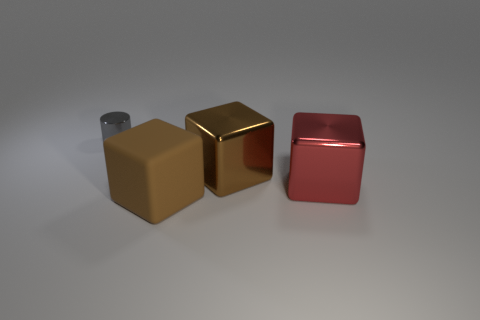How many other things are the same color as the rubber block?
Your response must be concise. 1. There is a large rubber object; does it have the same color as the large metallic block that is left of the red metallic cube?
Give a very brief answer. Yes. How many other small objects have the same shape as the gray thing?
Keep it short and to the point. 0. There is another large thing that is the same color as the rubber object; what is its material?
Provide a short and direct response. Metal. What number of large cyan balls are there?
Ensure brevity in your answer.  0. Is there a cylinder made of the same material as the red cube?
Offer a terse response. Yes. What is the size of the metal block that is the same color as the rubber thing?
Make the answer very short. Large. There is a brown cube that is to the right of the matte object; does it have the same size as the metal cylinder that is behind the large brown matte cube?
Make the answer very short. No. There is a brown object that is in front of the large red metallic thing; what is its size?
Make the answer very short. Large. Are there any big shiny things that have the same color as the metal cylinder?
Your answer should be compact. No. 